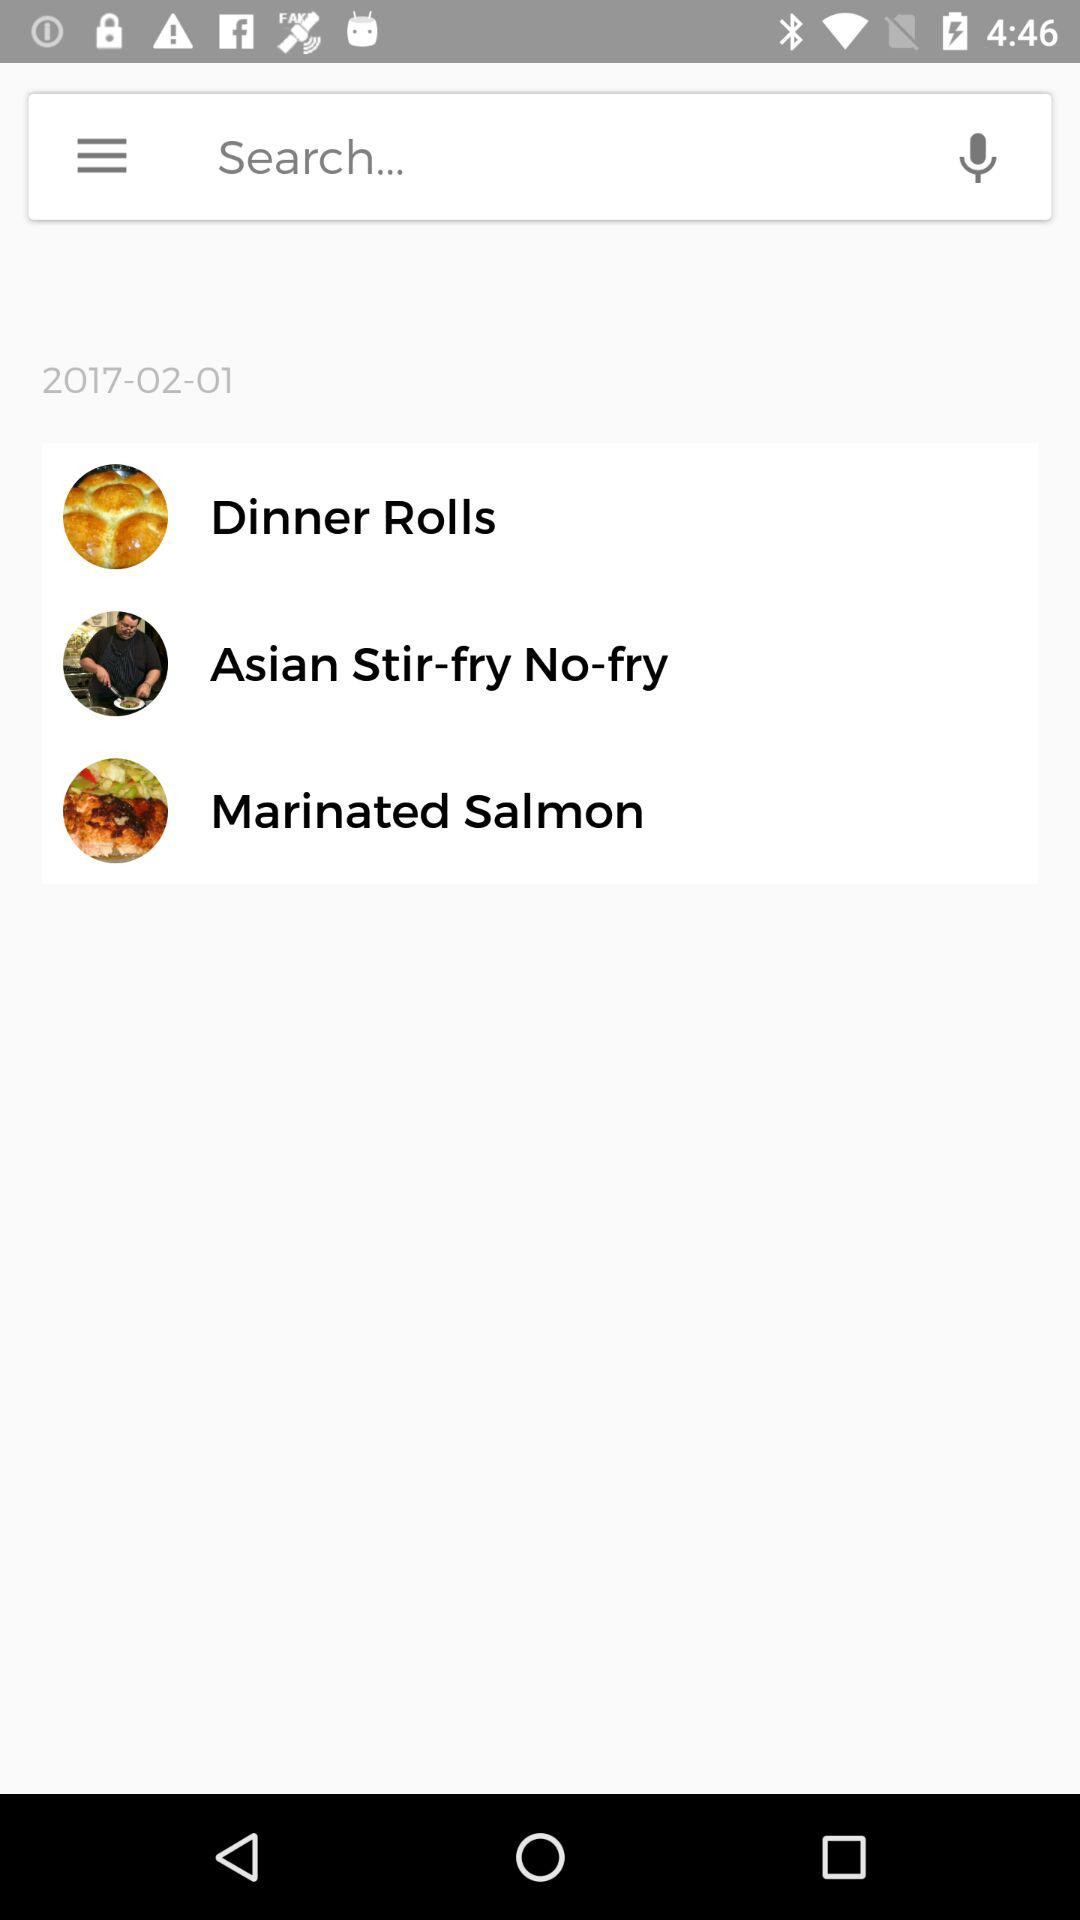What are the different available options? The different available options are "Dinner Rolls", "Asian Stir-fry No-fry" and "Marinated Salmon". 